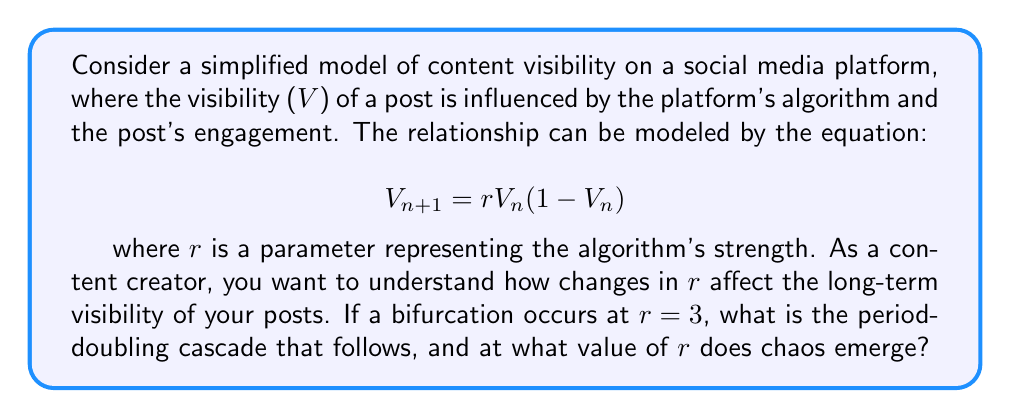Provide a solution to this math problem. To analyze this system and answer the question, we'll follow these steps:

1) The given equation is the logistic map, a classic example in dynamical systems that can exhibit various behaviors depending on the parameter $r$.

2) We know a bifurcation occurs at $r=3$. This is the first period-doubling bifurcation, where the system transitions from a stable fixed point to an oscillation between two values.

3) After $r=3$, further period-doubling bifurcations occur:
   - At $r \approx 3.449$, the system bifurcates from period-2 to period-4
   - At $r \approx 3.544$, it bifurcates from period-4 to period-8
   - At $r \approx 3.564$, it bifurcates from period-8 to period-16
   - This continues, with the intervals between bifurcations decreasing

4) The period-doubling cascade follows a geometric sequence. The ratio between successive bifurcation intervals converges to the Feigenbaum constant, approximately 4.669.

5) The accumulation point of this period-doubling cascade, where the period becomes infinite and chaos emerges, occurs at:

   $$r_{\infty} \approx 3.569946$$

   This value is known as the onset of chaos for the logistic map.

6) Beyond this point, the system exhibits mostly chaotic behavior, interspersed with occasional "windows" of periodic behavior.

As a content creator, this means that small changes in the algorithm (represented by $r$) can lead to dramatically different long-term visibility patterns for your content, especially as $r$ approaches and exceeds 3.57.
Answer: Period-doubling cascade: 3 → 3.449 → 3.544 → 3.564 → ...; Chaos emerges at $r \approx 3.569946$ 